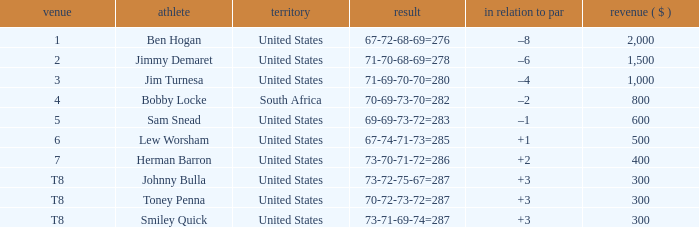What is the To par of the Player with a Score of 73-70-71-72=286? 2.0. 